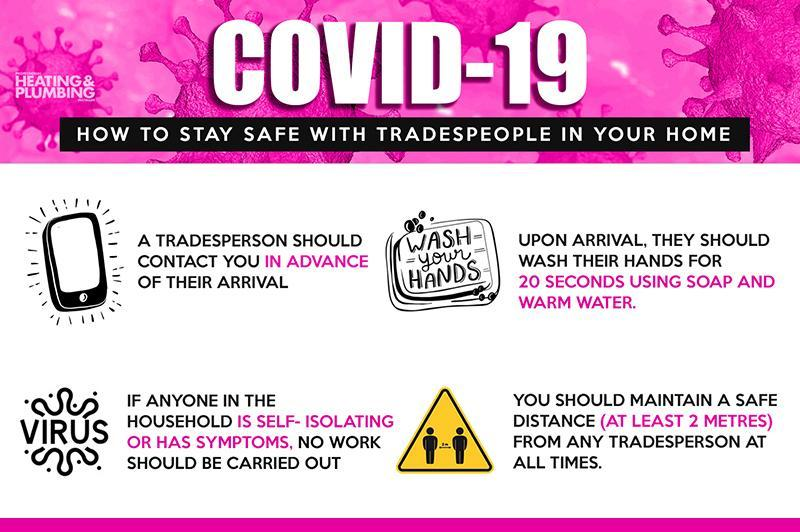What is the correct procedure to clean palms?
Answer the question with a short phrase. 20 seconds using soap and warm water What is the background color of the triangle- red, yellow, green, blue? yellow What is written inside the soap image? wash your hands How many persons are shown inside the triangle image? 2 What is the procedure to be done before the shopkeeper reaches the delivery destination? should contact you in advance 